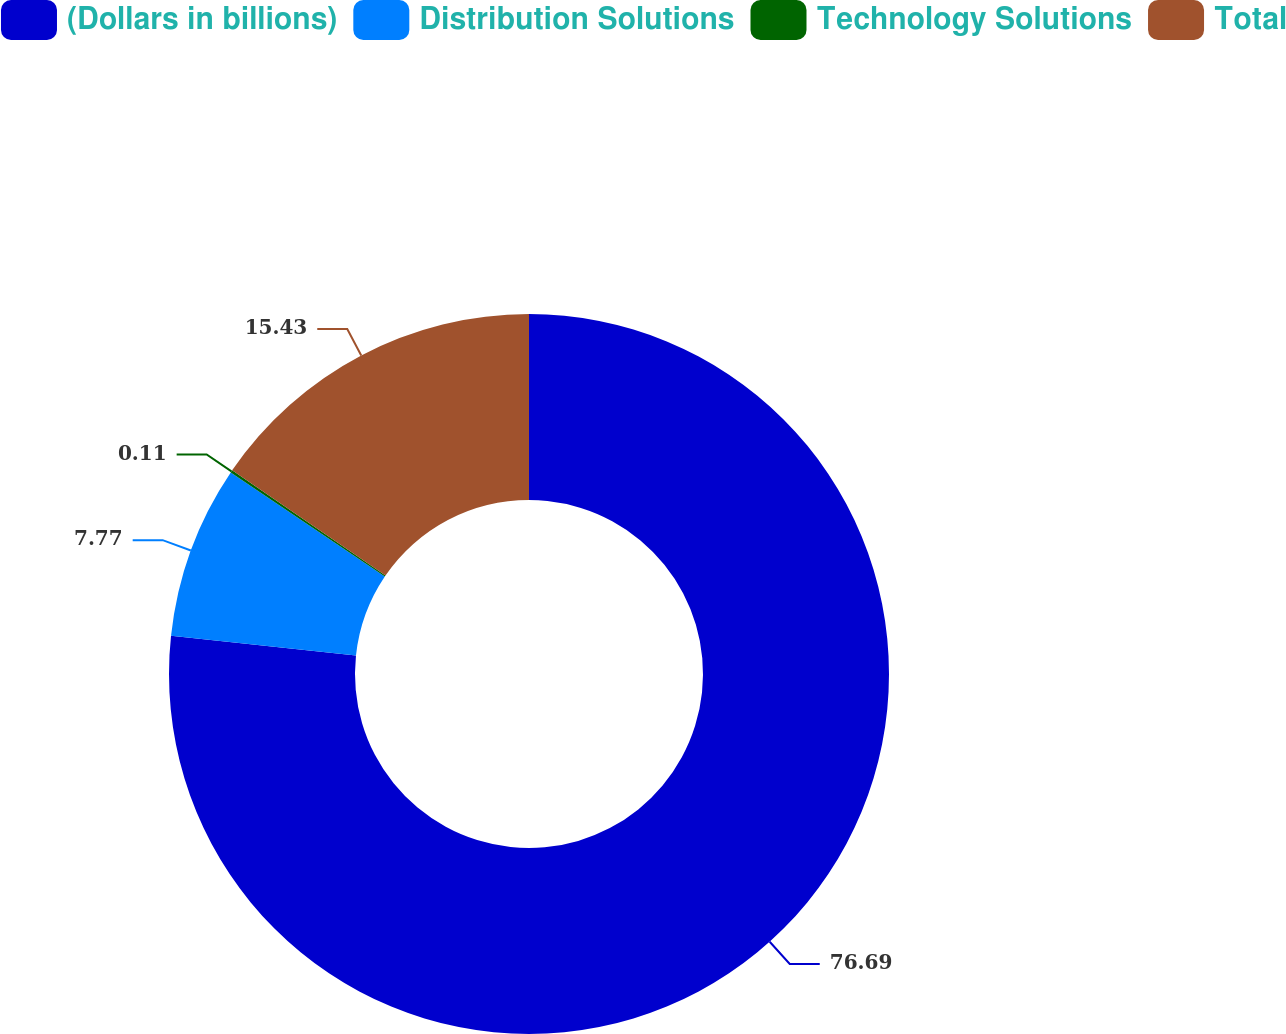Convert chart. <chart><loc_0><loc_0><loc_500><loc_500><pie_chart><fcel>(Dollars in billions)<fcel>Distribution Solutions<fcel>Technology Solutions<fcel>Total<nl><fcel>76.69%<fcel>7.77%<fcel>0.11%<fcel>15.43%<nl></chart> 